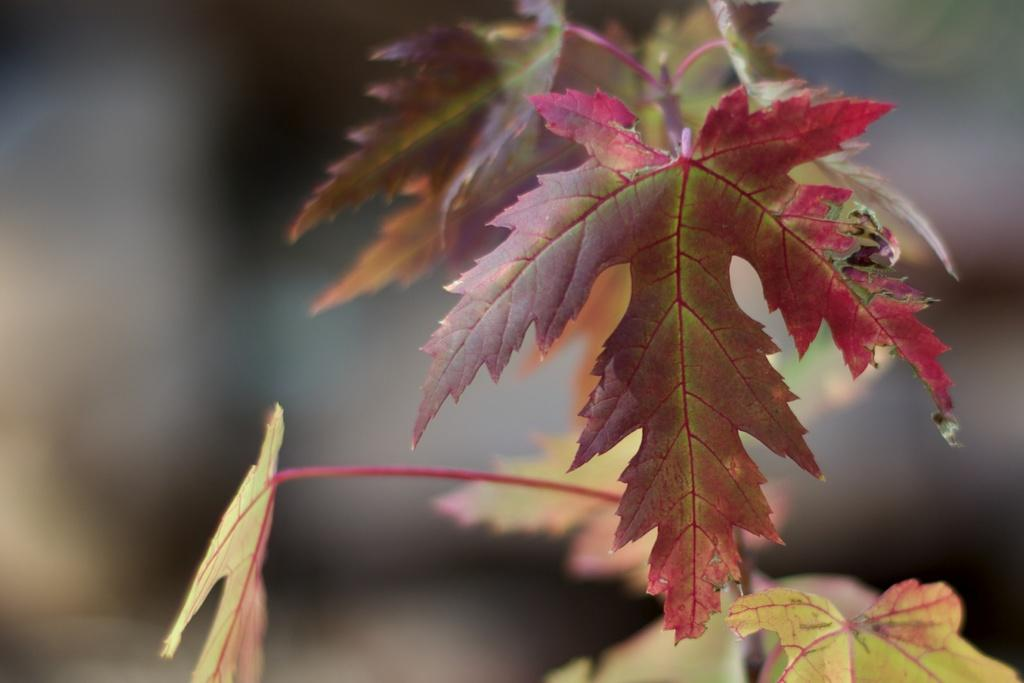What type of plant material can be seen in the image? There are leaves and a stem in the image. Can you describe the background of the image? The background of the image is blurred. What time of day is the class taking place in the image? There is no class or indication of time of day in the image; it only features leaves and a stem with a blurred background. 